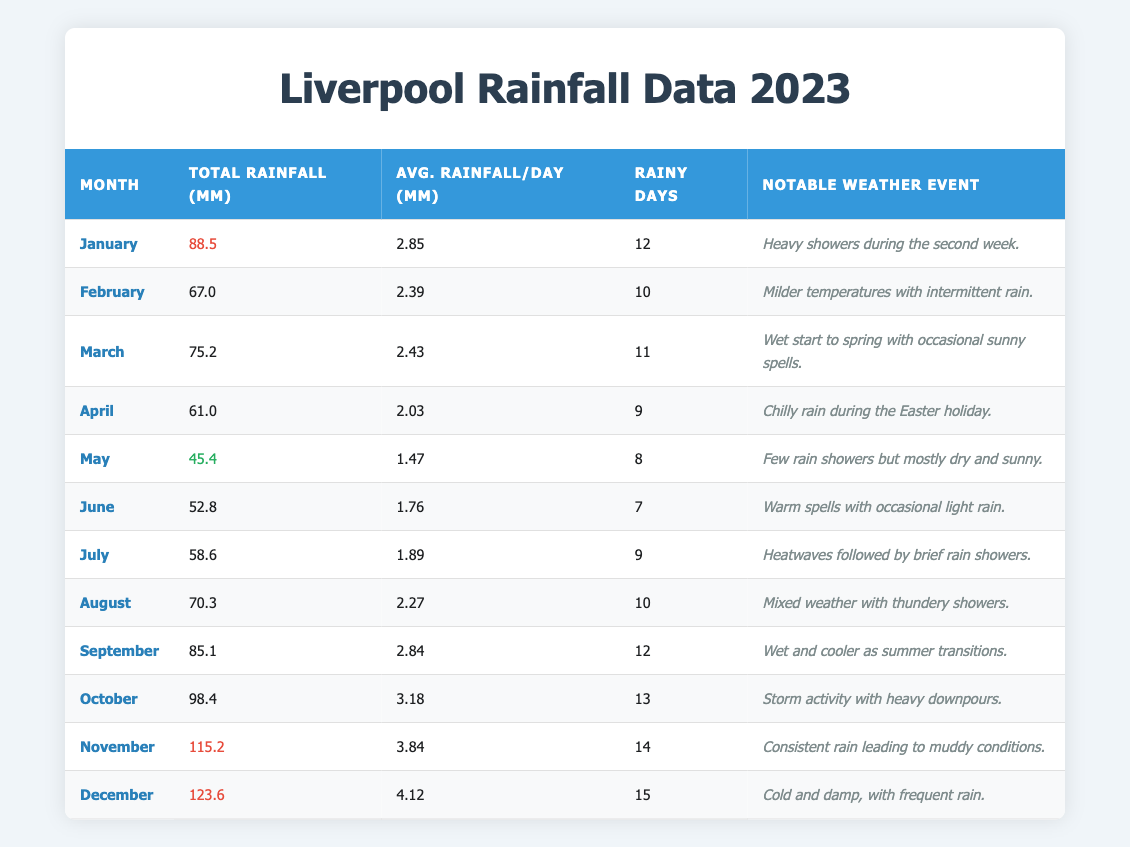What was the total rainfall in December? The table shows that the total rainfall in December is listed as 123.6 mm under the Total Rainfall column for that month.
Answer: 123.6 mm How many rainy days were there in July? According to the table, the entry for July states that there were 9 rainy days, which is found in the Rainy Days column.
Answer: 9 Which month had the least total rainfall? By examining the Total Rainfall column for all months, May records the least amount at 45.4 mm.
Answer: May What was the average rainfall per day in November? The Average Rainfall/Day column indicates that in November, the average rainfall per day was 3.84 mm, as noted in the corresponding row for November.
Answer: 3.84 mm Was there a notable weather event in March? The table includes an entry for March that specifies "Wet start to spring with occasional sunny spells" under the Notable Weather Event column, indicating that there was indeed an event.
Answer: Yes How much more rain fell in October than in April? The Total Rainfall for October is 98.4 mm and for April it is 61.0 mm. Calculating the difference: 98.4 mm - 61.0 mm = 37.4 mm, so October had 37.4 mm more rainfall than April.
Answer: 37.4 mm What was the average rainfall per day from January to March? To find the average for these months, the total rainfall amounts are 88.5 mm (January), 67.0 mm (February), and 75.2 mm (March). Summing these gives 88.5 + 67.0 + 75.2 = 230.7 mm over 3 months, then dividing by 90 days (30 + 28 + 31) results in approximately 2.57 mm per day.
Answer: 2.57 mm Which month had a notable weather event involving heavy showers? The table indicates that in January, there were "Heavy showers during the second week," thus it is the month with this event.
Answer: January If we consider only the months of the summer (June, July, August), what was the total rainfall? The rainfall data for these months is: June 52.8 mm, July 58.6 mm, August 70.3 mm. Adding these amounts gives 52.8 + 58.6 + 70.3 = 181.7 mm of total rainfall during the summer months.
Answer: 181.7 mm How many rainy days were there in total from January to June? The total number of rainy days from January (12), February (10), March (11), April (9), May (8), and June (7) sums up as 12 + 10 + 11 + 9 + 8 + 7 = 57 rainy days in total from January to June.
Answer: 57 